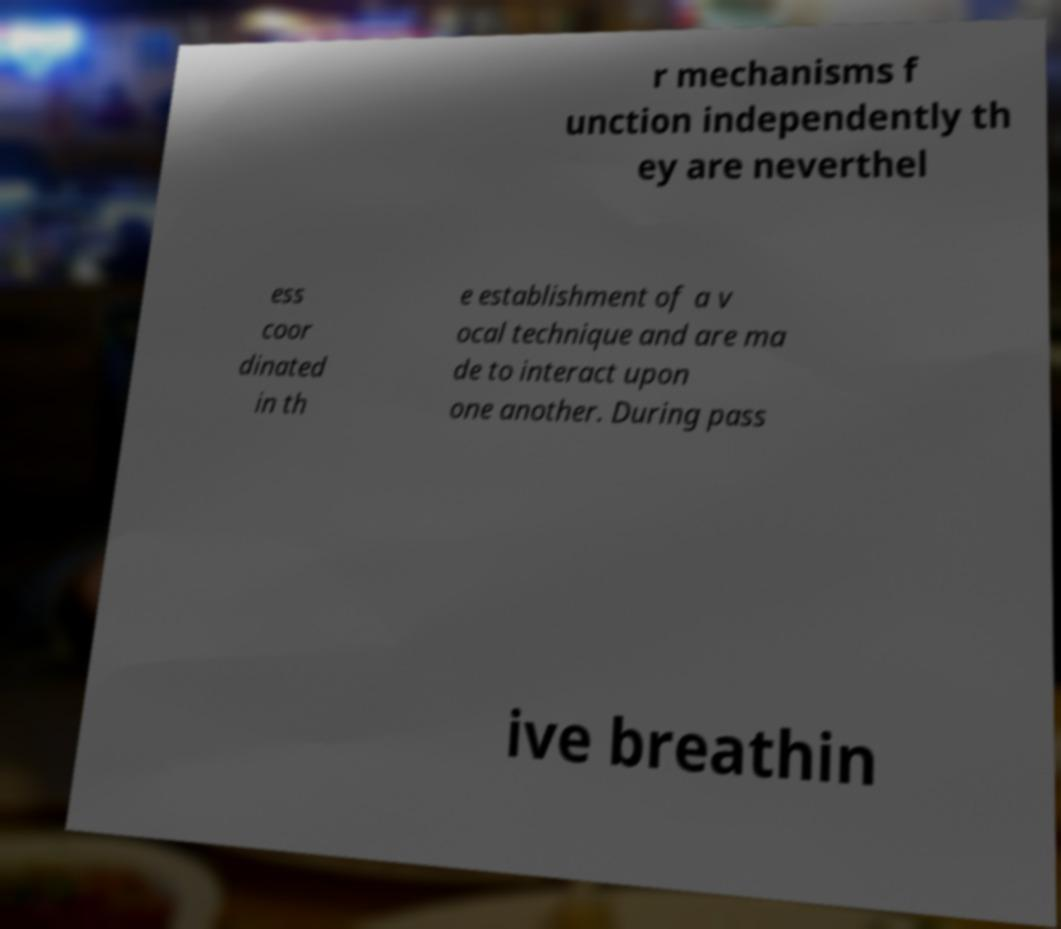There's text embedded in this image that I need extracted. Can you transcribe it verbatim? r mechanisms f unction independently th ey are neverthel ess coor dinated in th e establishment of a v ocal technique and are ma de to interact upon one another. During pass ive breathin 